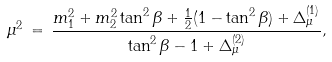<formula> <loc_0><loc_0><loc_500><loc_500>\mu ^ { 2 } \, = \, \frac { m _ { 1 } ^ { 2 } + m _ { 2 } ^ { 2 } \tan ^ { 2 } \beta + \frac { 1 } { 2 } ( 1 - \tan ^ { 2 } \beta ) + \Delta _ { \mu } ^ { ( 1 ) } } { \tan ^ { 2 } \beta - 1 + \Delta _ { \mu } ^ { ( 2 ) } } ,</formula> 